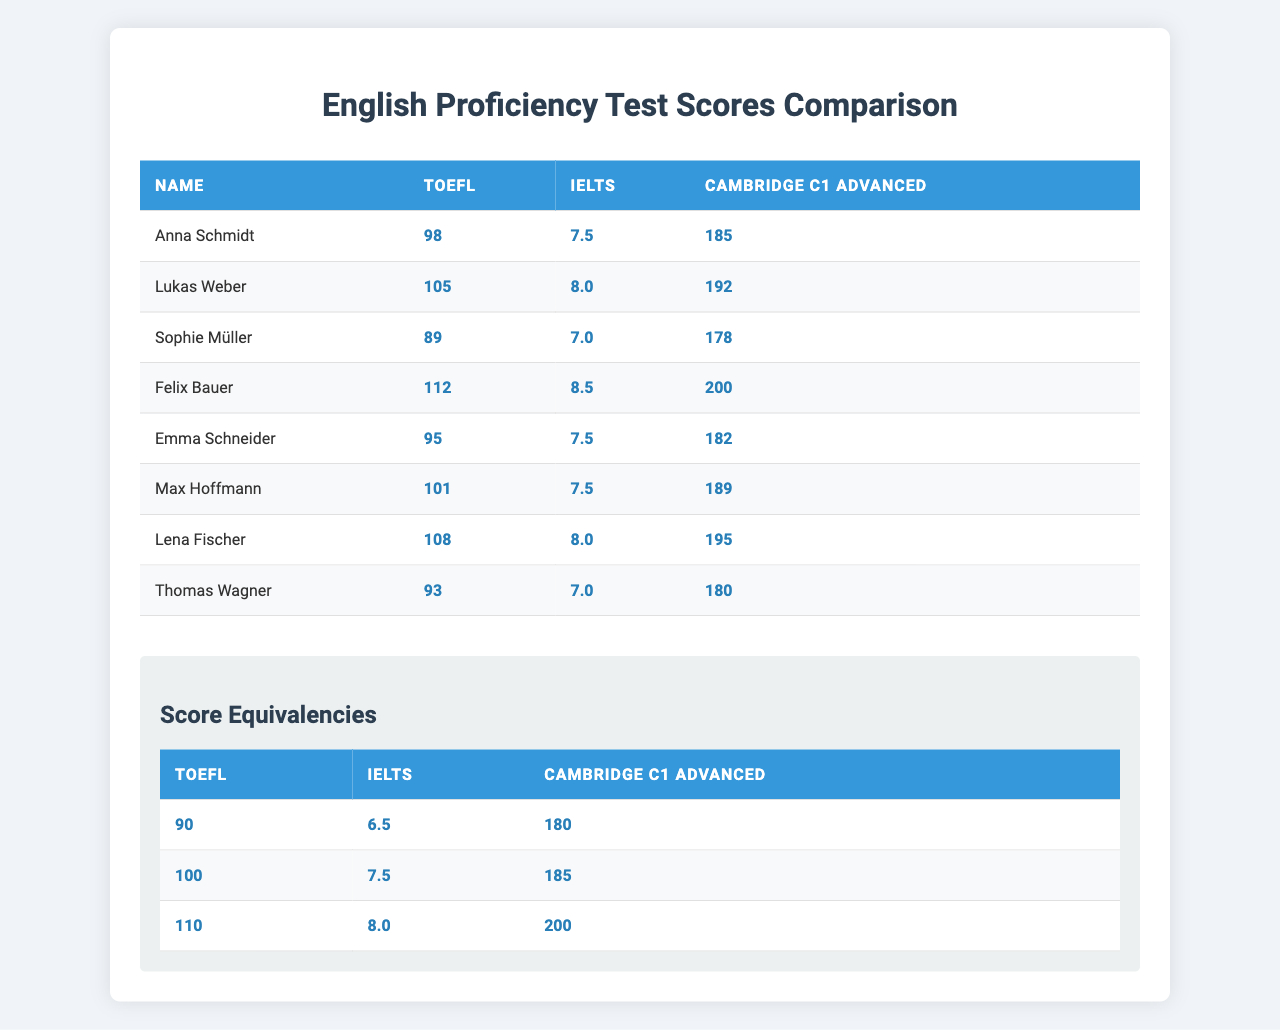What is the highest TOEFL score among the test takers? From the table, the scores for TOEFL are 98, 105, 89, 112, 95, 101, 108, and 93. The highest score listed is 112 by Felix Bauer.
Answer: 112 Who scored the lowest on the IELTS test? The IELTS scores are 7.5, 8.0, 7.0, 8.5, 7.5, 7.5, 8.0, and 7.0. The lowest score is 7.0, which was achieved by both Sophie Müller and Thomas Wagner.
Answer: 7.0 What is the equivalent Cambridge C1 Advanced score for a TOEFL score of 90? Referring to the equivalencies table, a TOEFL score of 90 corresponds to a Cambridge C1 Advanced score of 180.
Answer: 180 Who among the test takers scored at least 200 on the Cambridge C1 Advanced test? Looking at the scores for Cambridge C1 Advanced, only Felix Bauer scored 200.
Answer: Felix Bauer What is the average IELTS score of the test takers? The IELTS scores are 7.5, 8.0, 7.0, 8.5, 7.5, 7.5, 8.0, and 7.0. The sum of these scores is 56.0, and there are 8 test takers, so the average is 56.0 / 8 = 7.0.
Answer: 7.0 Is there anyone who scored the same in both IELTS and TOEFL? Checking the scores, there are no instances where the TOEFL and IELTS scores match; for example, if someone scored 95 in TOEFL, their IELTS score was 7.5, which is not equal.
Answer: No What is the total of all TOEFL scores? The TOEFL scores are 98, 105, 89, 112, 95, 101, 108, and 93. Adding these together gives 98 + 105 + 89 + 112 + 95 + 101 + 108 + 93 = 801.
Answer: 801 How many test takers scored above 200 on the Cambridge C1 Advanced? The scores for Cambridge C1 Advanced are 185, 192, 178, 200, 182, 189, 195, and 180. Only one person, Felix Bauer, scored above 200.
Answer: 1 What is the difference between the highest and lowest scores in the Cambridge C1 Advanced? The highest score is 200 and the lowest is 178. The difference is 200 - 178 = 22.
Answer: 22 Which test taker had the highest score in both TOEFL and IELTS? Checking the individual scores, Lukas Weber scored the highest in TOEFL with 105 and also scored 8.0 in IELTS. No one exceeded 8.5, making Felix Bauer the highest in IELTS. Therefore, Felix Bauer holds the highest IELTS score, while Lukas Weber has the highest TOEFL score. No one had the highest scores in both tests.
Answer: No one What is the average score of the Cambridge C1 Advanced test? The scores for Cambridge C1 Advanced are 185, 192, 178, 200, 182, 189, 195, and 180. The sum of these scores is 185 + 192 + 178 + 200 + 182 + 189 + 195 + 180 = 1411. There are 8 test takers, so the average score is 1411 / 8 = 176.375.
Answer: 176.375 